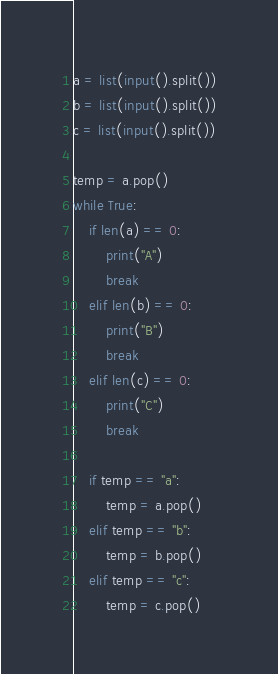<code> <loc_0><loc_0><loc_500><loc_500><_Python_>a = list(input().split())
b = list(input().split())
c = list(input().split())

temp = a.pop()
while True:
    if len(a) == 0:
        print("A")
        break
    elif len(b) == 0:
        print("B")
        break
    elif len(c) == 0:
        print("C")
        break

    if temp == "a":
        temp = a.pop()
    elif temp == "b":
        temp = b.pop()
    elif temp == "c":
        temp = c.pop()</code> 